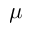<formula> <loc_0><loc_0><loc_500><loc_500>\mu</formula> 